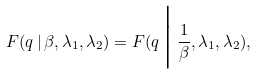Convert formula to latex. <formula><loc_0><loc_0><loc_500><loc_500>F ( q \, | \, \beta , \lambda _ { 1 } , \lambda _ { 2 } ) = F ( q \, \Big | \, \frac { 1 } { \beta } , \lambda _ { 1 } , \lambda _ { 2 } ) ,</formula> 